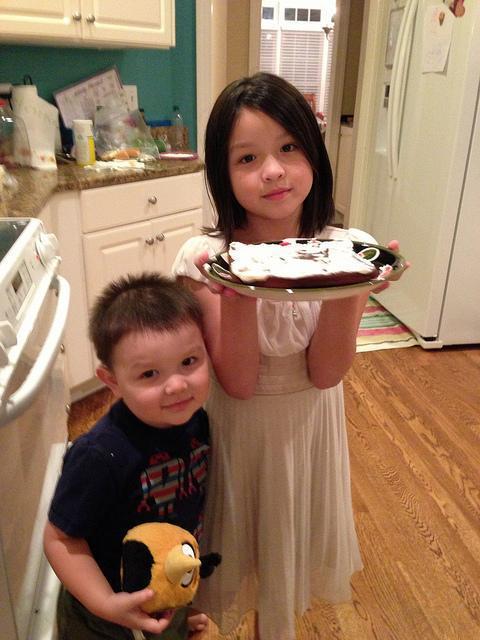How many people are there?
Give a very brief answer. 2. 